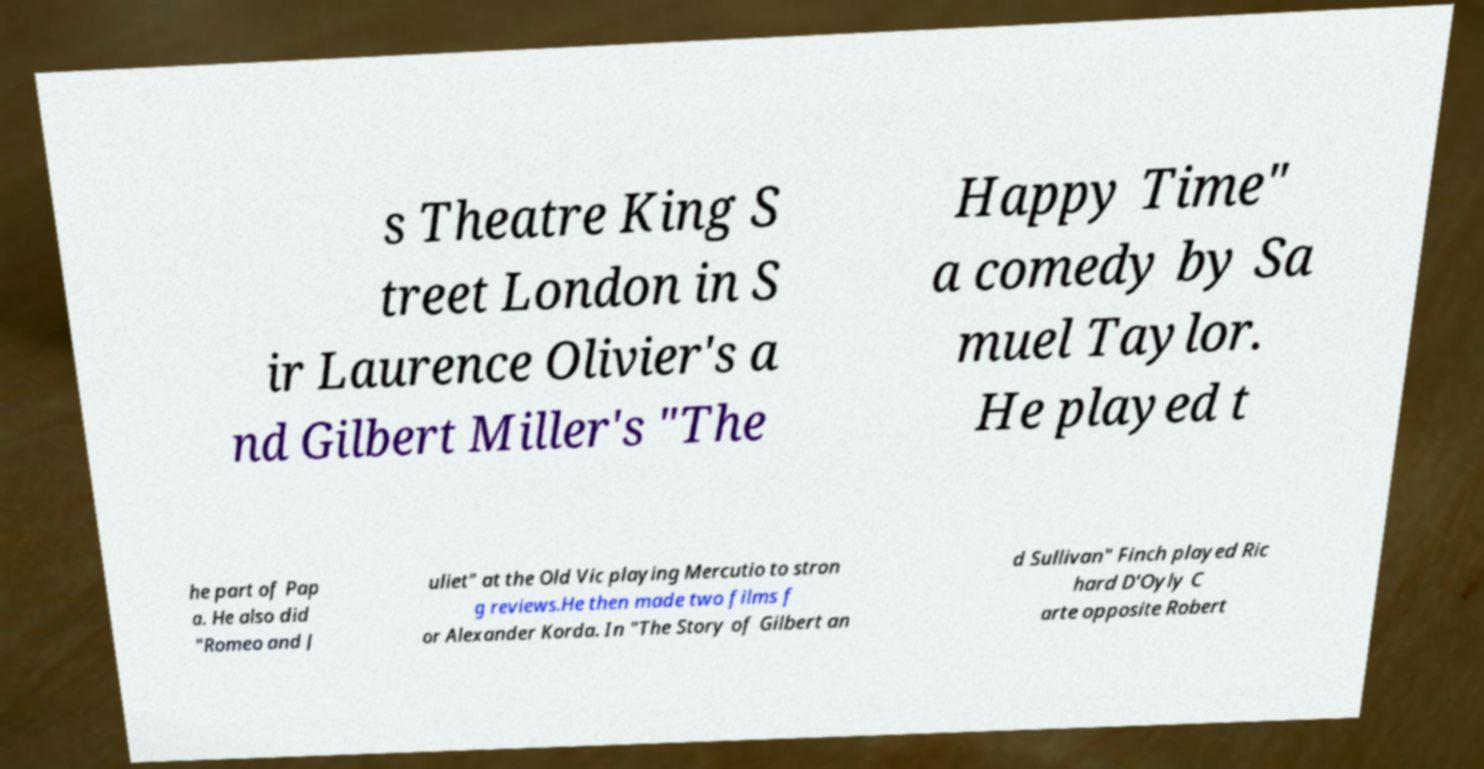For documentation purposes, I need the text within this image transcribed. Could you provide that? s Theatre King S treet London in S ir Laurence Olivier's a nd Gilbert Miller's "The Happy Time" a comedy by Sa muel Taylor. He played t he part of Pap a. He also did "Romeo and J uliet" at the Old Vic playing Mercutio to stron g reviews.He then made two films f or Alexander Korda. In "The Story of Gilbert an d Sullivan" Finch played Ric hard D'Oyly C arte opposite Robert 